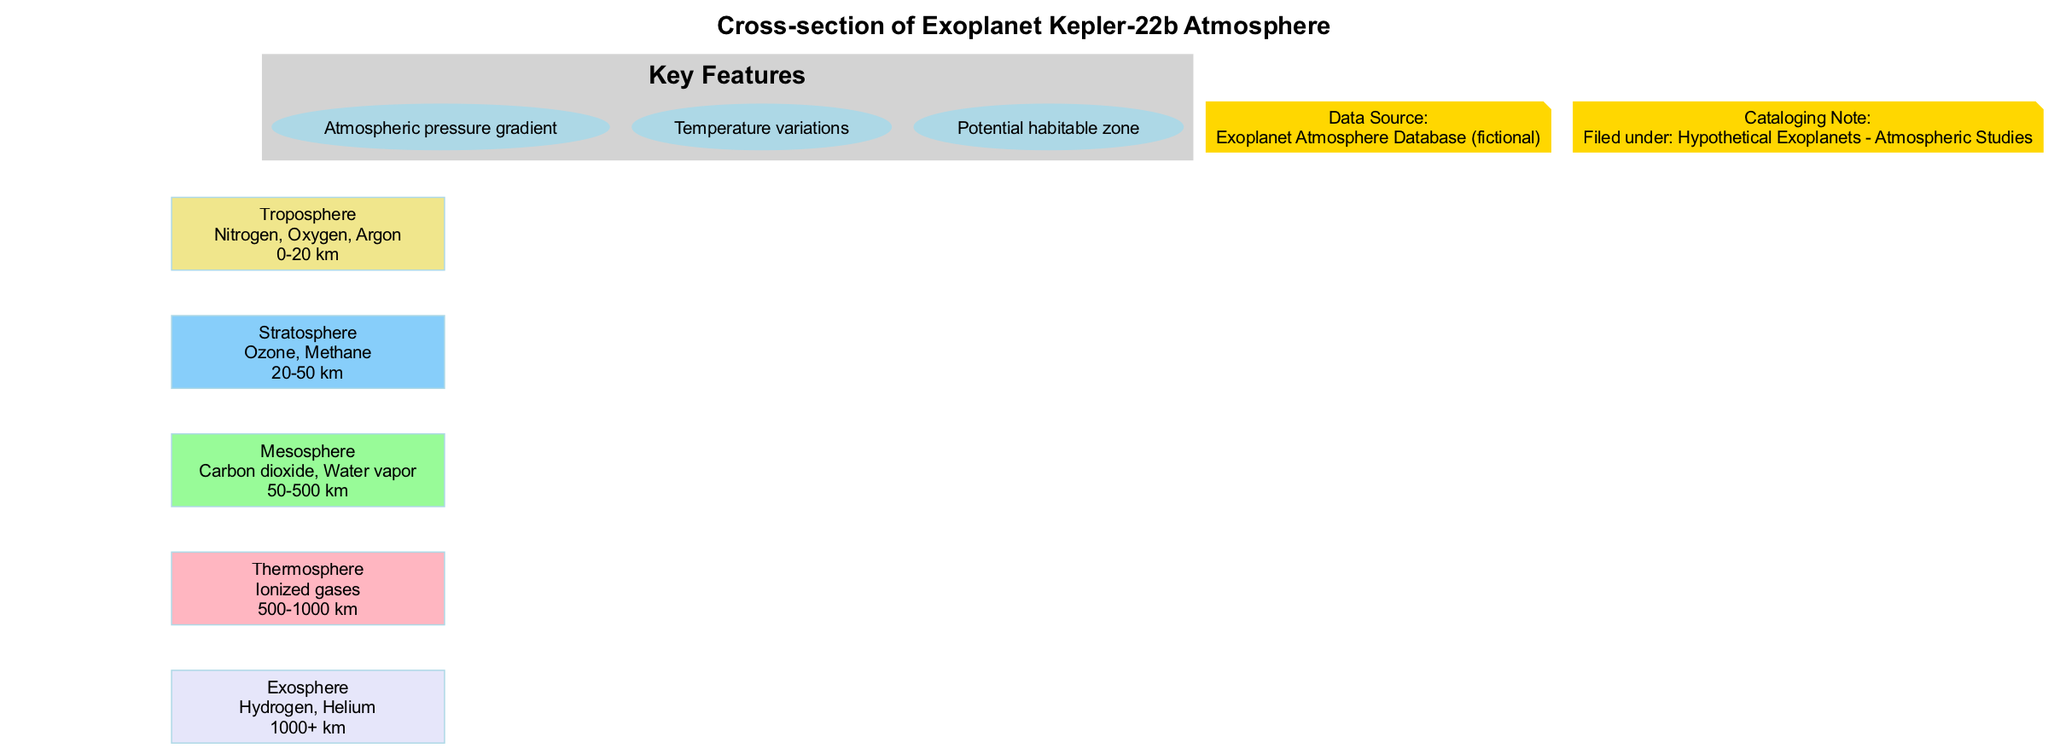What is the highest layer in the atmosphere? The highest layer in the atmosphere is identified as the "Exosphere" based on the layer arrangement shown in the diagram.
Answer: Exosphere What gases are present in the Stratosphere? The Stratosphere contains "Ozone" and "Methane" as indicated in its composition details in the diagram.
Answer: Ozone, Methane What is the altitude range of the Thermosphere? The range for the Thermosphere layer is specified as "500-1000 km", which can be found in the altitude section of the diagram for that layer.
Answer: 500-1000 km Which layer contains Nitrogen, Oxygen, and Argon? The layer containing these gases is the "Troposphere", as listed in the composition for that specific layer in the diagram.
Answer: Troposphere How many key features are highlighted in the diagram? The diagram includes a section labeled "Key Features" where three specific points are listed; hence, the total number of key features is counted as three.
Answer: 3 Which layer is located just above the Troposphere? The layer directly above the Troposphere is the "Stratosphere", based on the order of layers shown in the diagram.
Answer: Stratosphere What are the two gases that make up the Exosphere? The Exosphere is made up of "Hydrogen" and "Helium", which are stated in the composition details for that layer on the diagram.
Answer: Hydrogen, Helium What is the color representing the Mesosphere in the diagram? The color assigned to the Mesosphere layer is identified in the diagram legend which indicates it as a "light green" shade.
Answer: Light green What kind of atmospheric pressure trend is indicated in the diagram? The diagram describes the atmospheric pressure as having a "gradient" which suggests a decreasing trend with altitude.
Answer: Atmospheric pressure gradient 